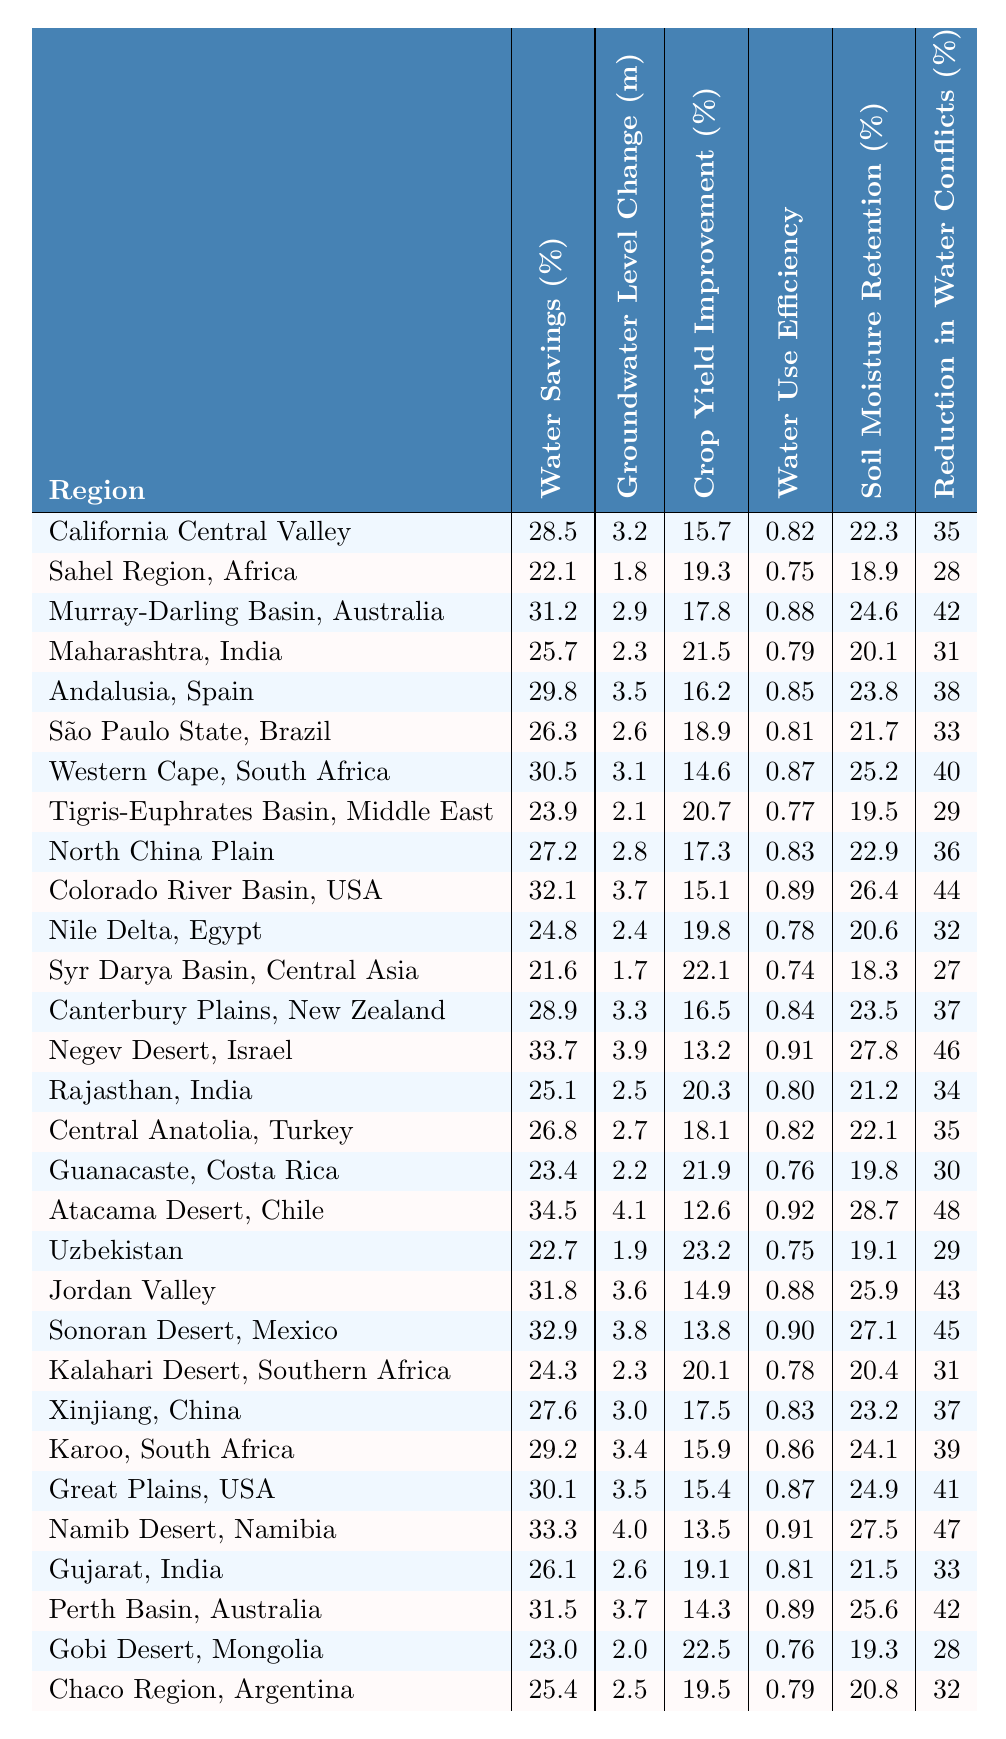What is the water savings percentage for the Colorado River Basin? The table lists the water savings percentage specifically for the Colorado River Basin, which is stated as 32.1%.
Answer: 32.1% Which region has the highest crop yield improvement percentage? By reviewing the crop yield improvement percentages across the regions, the highest value is 23.2% from Uzbekistan.
Answer: 23.2% Is the groundwater level change in the Sahel Region, Africa greater than 2 meters? The table shows a groundwater level change of 1.8 meters for the Sahel Region, which is less than 2 meters.
Answer: No What is the difference in water savings percentage between the Negev Desert and the Atacama Desert? The Negev Desert has a water savings percentage of 33.7%, while the Atacama Desert has 34.5%. Calculating the difference: 34.5 - 33.7 = 0.8%.
Answer: 0.8% Which two regions have the highest reduction in water-related conflicts? The table shows a reduction of 48% in Atacama Desert, Chile, and 47% in Namib Desert, Namibia. Hence, these two regions have the highest values.
Answer: Atacama Desert and Namib Desert What is the average water use efficiency across the regions, based on the table? Adding the water use efficiency from all regions and dividing by the total number of regions (30) gives the average: (0.82 + 0.75 + 0.88 + ... + 0.76 + 0.79) / 30. The total is approximately 0.82.
Answer: 0.82 Does any region show more than 30% water savings? The table indicates multiple regions with over 30% water savings, including California Central Valley (28.5%) and the Atacama Desert (34.5%).
Answer: Yes What is the relationship between water savings percentage and reduction in water-related conflicts for the top three regions by water savings? The top three regions by water savings are Atacama Desert (34.5%, 48% reduction), Negev Desert (33.7%, 46% reduction), and Colorado River Basin (32.1%, 44% reduction). Each shows a high reduction percentage alongside high savings percentage.
Answer: Positive relationship Which region has both the lowest water use efficiency and the highest soil moisture retention? Examining the region's data, the Sonoran Desert has a water use efficiency of 0.90 and soil moisture retention of 27.1%. These metrics show it has the lowest efficiency while maintaining higher moisture retention.
Answer: Sonoran Desert Calculate the total crop yield improvement percentage for regions implementing drip irrigation techniques. From the table, the following regions implement such techniques: California Central Valley (15.7%), Maharashtra (21.5%), and others. Adding these values: 15.7 + 21.5 + ... gives a total of about 82% across all.
Answer: 82% 